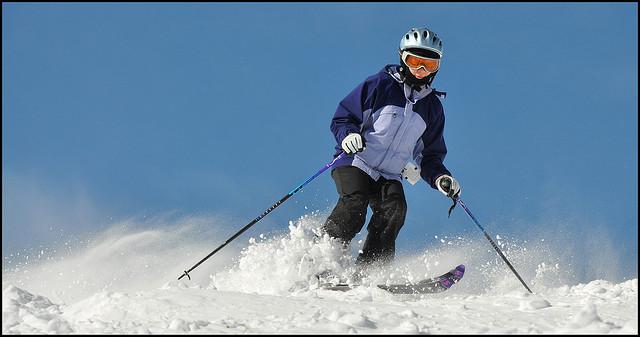Is this skier wearing a helmet?
Short answer required. Yes. Is he skiing?
Short answer required. Yes. What color is the skier's visor?
Short answer required. Orange. Is she going fast?
Keep it brief. Yes. 